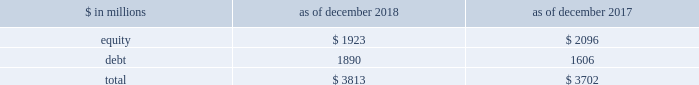The goldman sachs group , inc .
And subsidiaries management 2019s discussion and analysis during periods in which we have significantly more positive net revenue days than net revenue loss days , we expect to have fewer var exceptions because , under normal conditions , our business model generally produces positive net revenues .
In periods in which our franchise revenues are adversely affected , we generally have more loss days , resulting in more var exceptions .
The daily net revenues for positions included in var used to determine var exceptions reflect the impact of any intraday activity , including bid/offer net revenues , which are more likely than not to be positive by their nature .
Sensitivity measures certain portfolios and individual positions are not included in var because var is not the most appropriate risk measure .
Other sensitivity measures we use to analyze market risk are described below .
10% ( 10 % ) sensitivity measures .
The table below presents market risk by asset category for positions accounted for at fair value , that are not included in var. .
In the table above : 2030 the market risk of these positions is determined by estimating the potential reduction in net revenues of a 10% ( 10 % ) decline in the value of these positions .
2030 equity positions relate to private and restricted public equity securities , including interests in funds that invest in corporate equities and real estate and interests in hedge funds .
2030 debt positions include interests in funds that invest in corporate mezzanine and senior debt instruments , loans backed by commercial and residential real estate , corporate bank loans and other corporate debt , including acquired portfolios of distressed loans .
2030 funded equity and debt positions are included in our consolidated statements of financial condition in financial instruments owned .
See note 6 to the consolidated financial statements for further information about cash instruments .
2030 these measures do not reflect the diversification effect across asset categories or across other market risk measures .
Credit spread sensitivity on derivatives and financial liabilities .
Var excludes the impact of changes in counterparty and our own credit spreads on derivatives , as well as changes in our own credit spreads ( debt valuation adjustment ) on financial liabilities for which the fair value option was elected .
The estimated sensitivity to a one basis point increase in credit spreads ( counterparty and our own ) on derivatives was a gain of $ 3 million ( including hedges ) as of both december 2018 and december 2017 .
In addition , the estimated sensitivity to a one basis point increase in our own credit spreads on financial liabilities for which the fair value option was elected was a gain of $ 41 million as of december 2018 and $ 35 million as of december 2017 .
However , the actual net impact of a change in our own credit spreads is also affected by the liquidity , duration and convexity ( as the sensitivity is not linear to changes in yields ) of those financial liabilities for which the fair value option was elected , as well as the relative performance of any hedges undertaken .
Interest rate sensitivity .
Loans receivable were $ 80.59 billion as of december 2018 and $ 65.93 billion as of december 2017 , substantially all of which had floating interest rates .
The estimated sensitivity to a 100 basis point increase in interest rates on such loans was $ 607 million as of december 2018 and $ 527 million as of december 2017 , of additional interest income over a twelve-month period , which does not take into account the potential impact of an increase in costs to fund such loans .
See note 9 to the consolidated financial statements for further information about loans receivable .
Other market risk considerations as of both december 2018 and december 2017 , we had commitments and held loans for which we have obtained credit loss protection from sumitomo mitsui financial group , inc .
See note 18 to the consolidated financial statements for further information about such lending commitments .
In addition , we make investments in securities that are accounted for as available-for-sale and included in financial instruments owned in the consolidated statements of financial condition .
See note 6 to the consolidated financial statements for further information .
We also make investments accounted for under the equity method and we also make direct investments in real estate , both of which are included in other assets .
Direct investments in real estate are accounted for at cost less accumulated depreciation .
See note 13 to the consolidated financial statements for further information about other assets .
92 goldman sachs 2018 form 10-k .
What is the debt-to-equity ratio in 2018? 
Computations: (1890 / 1923)
Answer: 0.98284. The goldman sachs group , inc .
And subsidiaries management 2019s discussion and analysis during periods in which we have significantly more positive net revenue days than net revenue loss days , we expect to have fewer var exceptions because , under normal conditions , our business model generally produces positive net revenues .
In periods in which our franchise revenues are adversely affected , we generally have more loss days , resulting in more var exceptions .
The daily net revenues for positions included in var used to determine var exceptions reflect the impact of any intraday activity , including bid/offer net revenues , which are more likely than not to be positive by their nature .
Sensitivity measures certain portfolios and individual positions are not included in var because var is not the most appropriate risk measure .
Other sensitivity measures we use to analyze market risk are described below .
10% ( 10 % ) sensitivity measures .
The table below presents market risk by asset category for positions accounted for at fair value , that are not included in var. .
In the table above : 2030 the market risk of these positions is determined by estimating the potential reduction in net revenues of a 10% ( 10 % ) decline in the value of these positions .
2030 equity positions relate to private and restricted public equity securities , including interests in funds that invest in corporate equities and real estate and interests in hedge funds .
2030 debt positions include interests in funds that invest in corporate mezzanine and senior debt instruments , loans backed by commercial and residential real estate , corporate bank loans and other corporate debt , including acquired portfolios of distressed loans .
2030 funded equity and debt positions are included in our consolidated statements of financial condition in financial instruments owned .
See note 6 to the consolidated financial statements for further information about cash instruments .
2030 these measures do not reflect the diversification effect across asset categories or across other market risk measures .
Credit spread sensitivity on derivatives and financial liabilities .
Var excludes the impact of changes in counterparty and our own credit spreads on derivatives , as well as changes in our own credit spreads ( debt valuation adjustment ) on financial liabilities for which the fair value option was elected .
The estimated sensitivity to a one basis point increase in credit spreads ( counterparty and our own ) on derivatives was a gain of $ 3 million ( including hedges ) as of both december 2018 and december 2017 .
In addition , the estimated sensitivity to a one basis point increase in our own credit spreads on financial liabilities for which the fair value option was elected was a gain of $ 41 million as of december 2018 and $ 35 million as of december 2017 .
However , the actual net impact of a change in our own credit spreads is also affected by the liquidity , duration and convexity ( as the sensitivity is not linear to changes in yields ) of those financial liabilities for which the fair value option was elected , as well as the relative performance of any hedges undertaken .
Interest rate sensitivity .
Loans receivable were $ 80.59 billion as of december 2018 and $ 65.93 billion as of december 2017 , substantially all of which had floating interest rates .
The estimated sensitivity to a 100 basis point increase in interest rates on such loans was $ 607 million as of december 2018 and $ 527 million as of december 2017 , of additional interest income over a twelve-month period , which does not take into account the potential impact of an increase in costs to fund such loans .
See note 9 to the consolidated financial statements for further information about loans receivable .
Other market risk considerations as of both december 2018 and december 2017 , we had commitments and held loans for which we have obtained credit loss protection from sumitomo mitsui financial group , inc .
See note 18 to the consolidated financial statements for further information about such lending commitments .
In addition , we make investments in securities that are accounted for as available-for-sale and included in financial instruments owned in the consolidated statements of financial condition .
See note 6 to the consolidated financial statements for further information .
We also make investments accounted for under the equity method and we also make direct investments in real estate , both of which are included in other assets .
Direct investments in real estate are accounted for at cost less accumulated depreciation .
See note 13 to the consolidated financial statements for further information about other assets .
92 goldman sachs 2018 form 10-k .
What is the debt-to-equity ratio in 2017? 
Computations: (1606 / 2096)
Answer: 0.76622. 